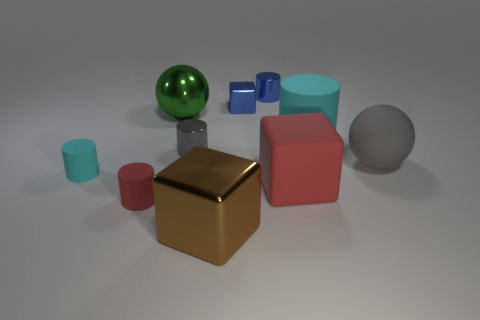What number of matte objects are the same color as the big rubber cylinder?
Offer a terse response. 1. The tiny rubber object to the right of the cyan cylinder in front of the gray thing that is right of the tiny gray cylinder is what shape?
Keep it short and to the point. Cylinder. What size is the red cylinder that is made of the same material as the big gray sphere?
Ensure brevity in your answer.  Small. Are there more shiny balls than tiny green spheres?
Your answer should be compact. Yes. There is a red thing that is the same size as the green ball; what is its material?
Give a very brief answer. Rubber. There is a metal cube that is on the left side of the blue block; is its size the same as the tiny red cylinder?
Offer a terse response. No. What number of cylinders are matte things or red matte things?
Offer a very short reply. 3. What material is the cube that is behind the tiny cyan rubber cylinder?
Your answer should be compact. Metal. Is the number of tiny gray cylinders less than the number of big yellow matte objects?
Provide a short and direct response. No. What is the size of the cylinder that is on the right side of the red rubber cylinder and in front of the big cyan object?
Your answer should be very brief. Small. 